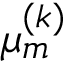<formula> <loc_0><loc_0><loc_500><loc_500>\mu _ { m } ^ { ( k ) }</formula> 